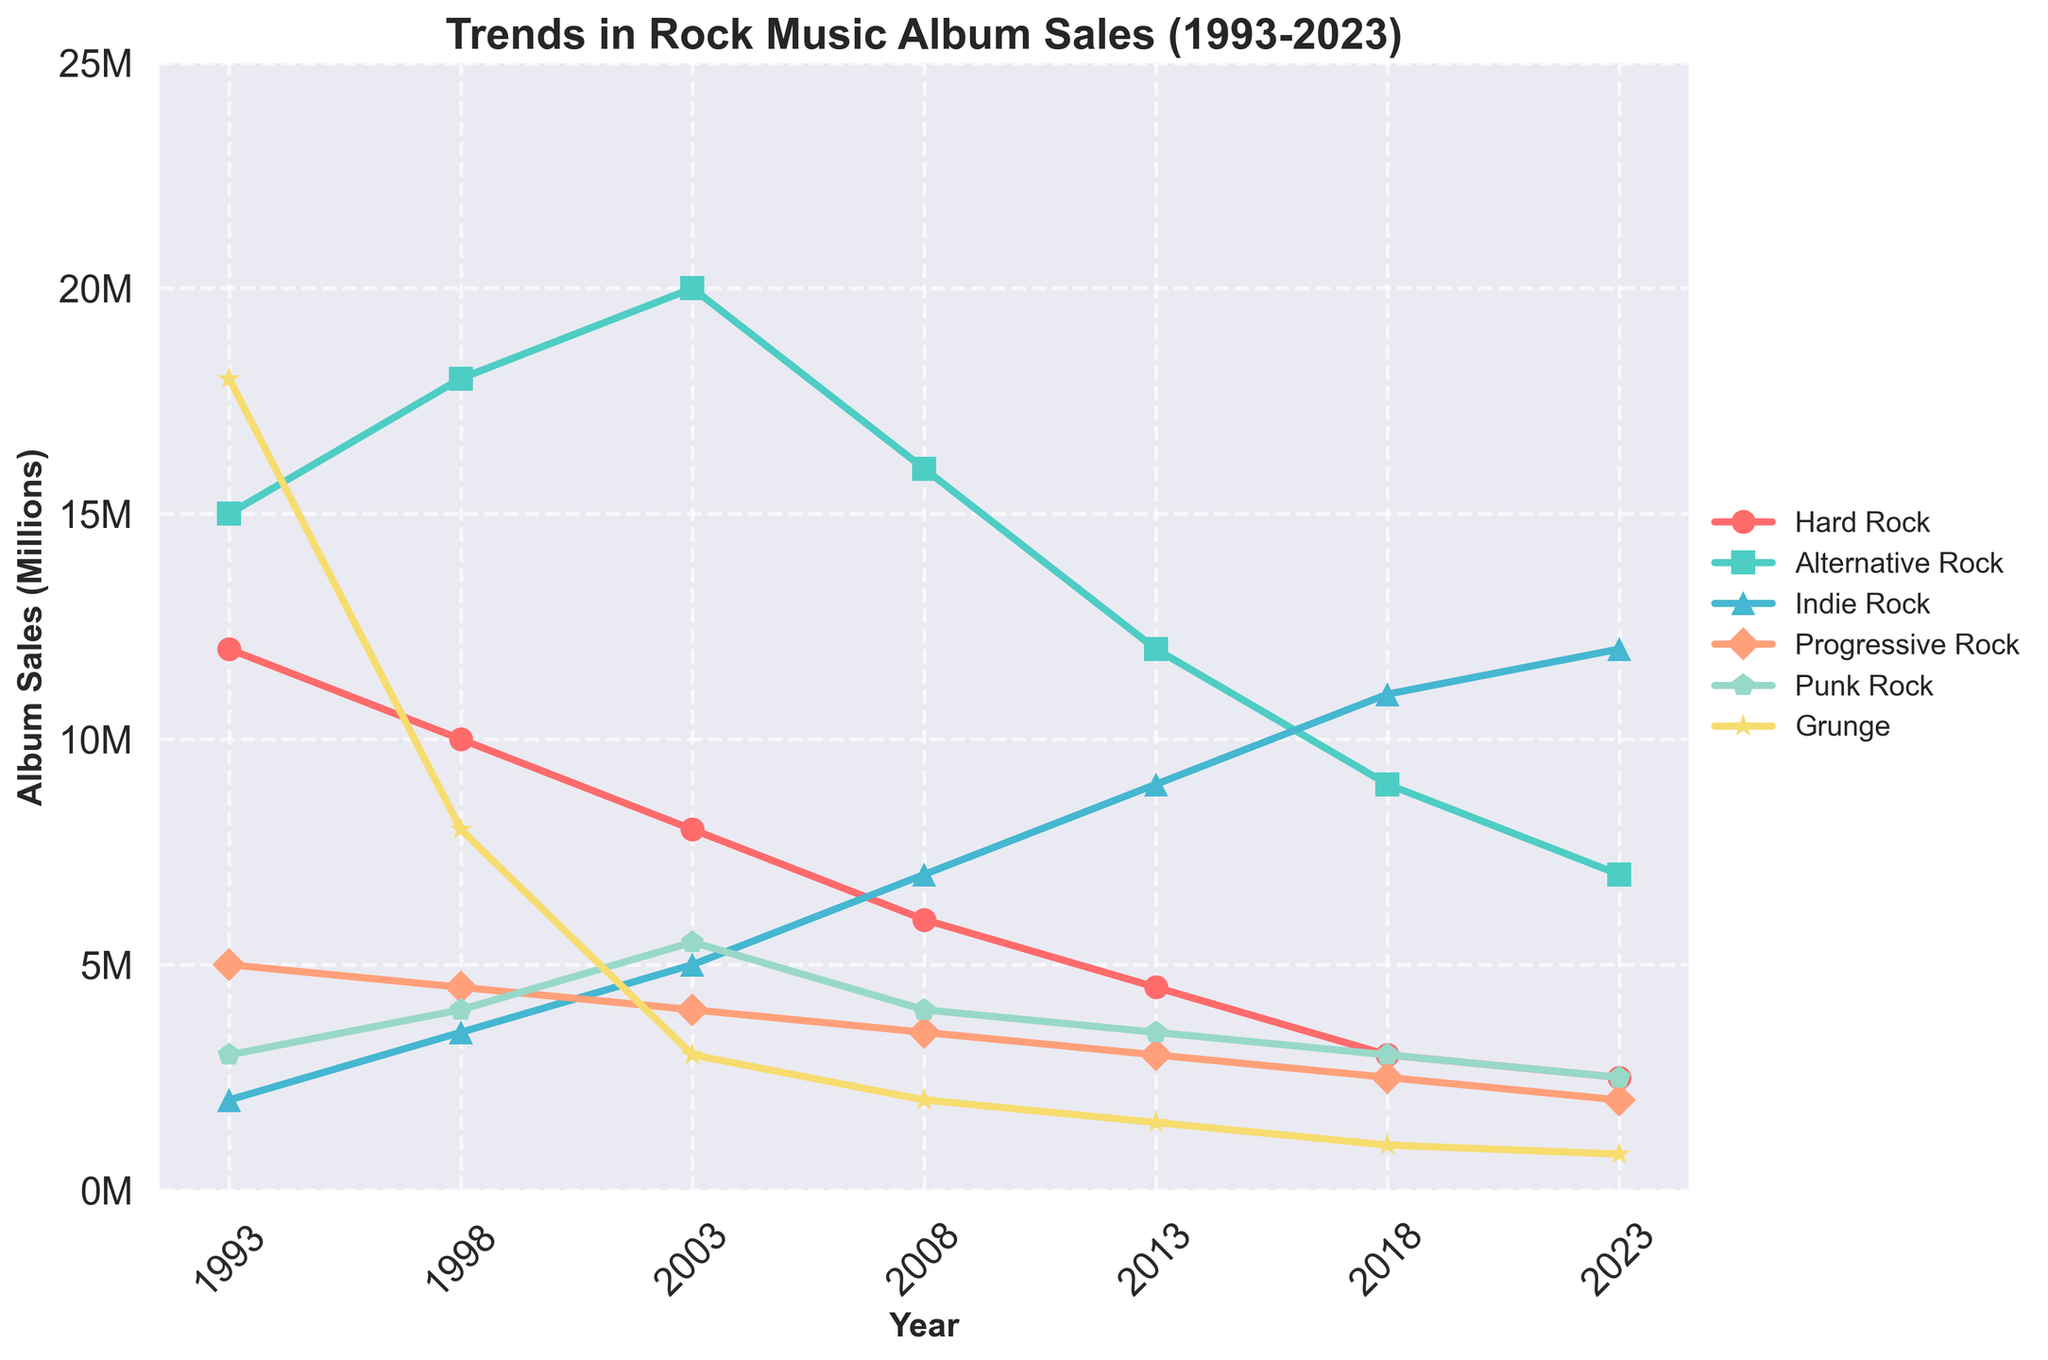What is the overall trend for Hard Rock album sales from 1993 to 2023? To determine the trend, look at the sales data points for Hard Rock over the given years. From 1993 to 2023, sales steadily decrease from 12 million to 2.5 million.
Answer: Decreasing Which subgenre had the highest album sales in 2003? Compare the sales figures for each subgenre in 2003. Alternative Rock had the highest sales with 20 million albums.
Answer: Alternative Rock How much did Grunge album sales drop from 1993 to 2023? Subtract the 2023 sales (0.8 million) from the 1993 sales (18 million). This results in a drop of 17.2 million albums.
Answer: 17.2 million Which subgenre showed the most consistent decline over the 30-year period? By examining the trends for all subgenres, Hard Rock shows a consistent decline without any major spikes or increases.
Answer: Hard Rock In what year did Indie Rock album sales surpass Hard Rock album sales? Cross-reference the sales figures for both subgenres. This first happens in 2008 when Indie Rock rises to 7 million while Hard Rock drops to 6 million.
Answer: 2008 What are the differences in sales between Alternative Rock and Punk Rock in 2013? Subtract Punk Rock sales (3.5 million) from Alternative Rock sales (12 million). The difference is 8.5 million albums.
Answer: 8.5 million By how much did album sales for Progressive Rock change from 1998 to 2008? Subtract the 2008 sales (3.5 million) from the 1998 sales (4.5 million). This results in a change of -1 million albums.
Answer: -1 million What trend do you observe for Grunge album sales from 2003 to 2023? Observe the sales data points for Grunge between 2003 and 2023. Sales consistently decrease from 3 million to 0.8 million.
Answer: Decreasing Which subgenres outperformed Hard Rock in 2023? Compare album sales of each subgenre with Hard Rock in 2023. Alternative Rock with 7 million and Indie Rock with 12 million outperformed Hard Rock's 2.5 million.
Answer: Alternative Rock, Indie Rock What is the sum of album sales for Punk Rock over the last three decades? Add all Punk Rock sales figures together: 3 million + 4 million + 5.5 million + 4 million + 3.5 million + 3 million + 2.5 million = 25.5 million.
Answer: 25.5 million 